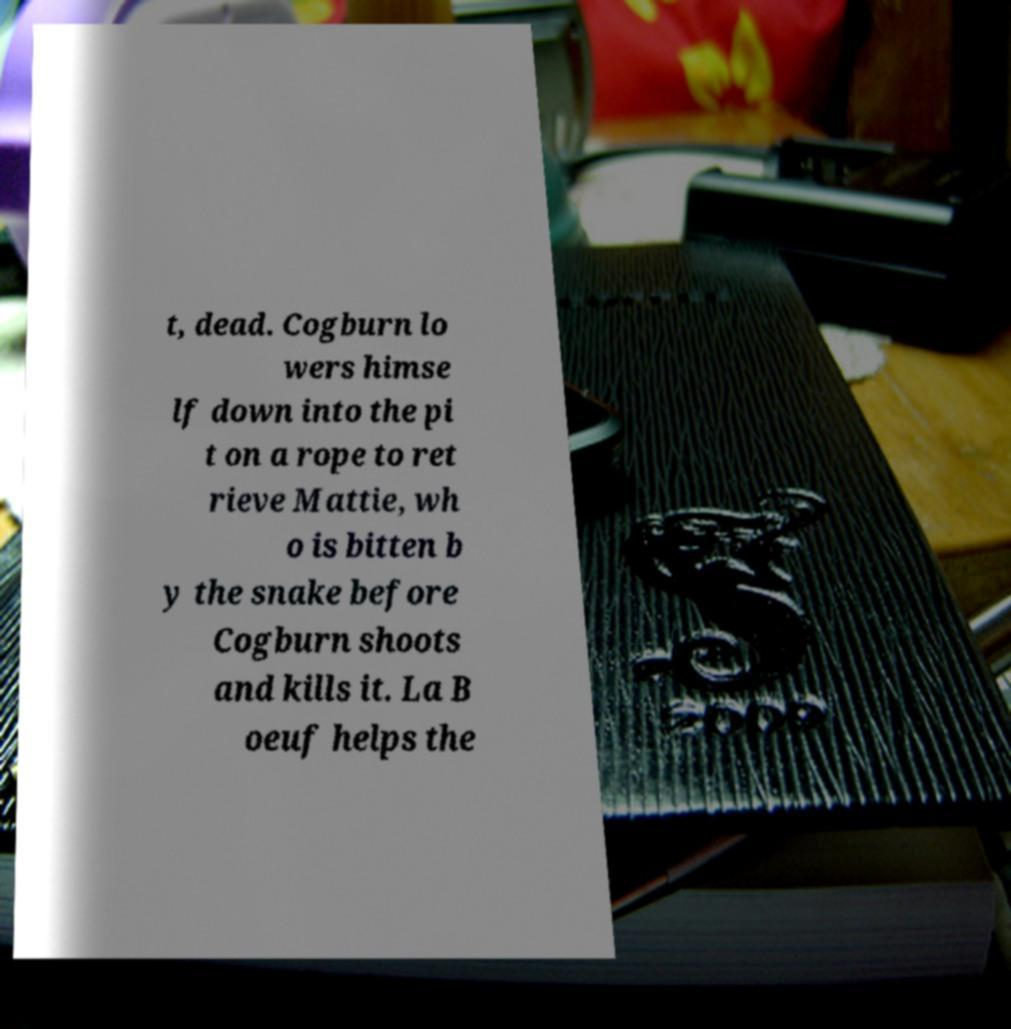Can you read and provide the text displayed in the image?This photo seems to have some interesting text. Can you extract and type it out for me? t, dead. Cogburn lo wers himse lf down into the pi t on a rope to ret rieve Mattie, wh o is bitten b y the snake before Cogburn shoots and kills it. La B oeuf helps the 